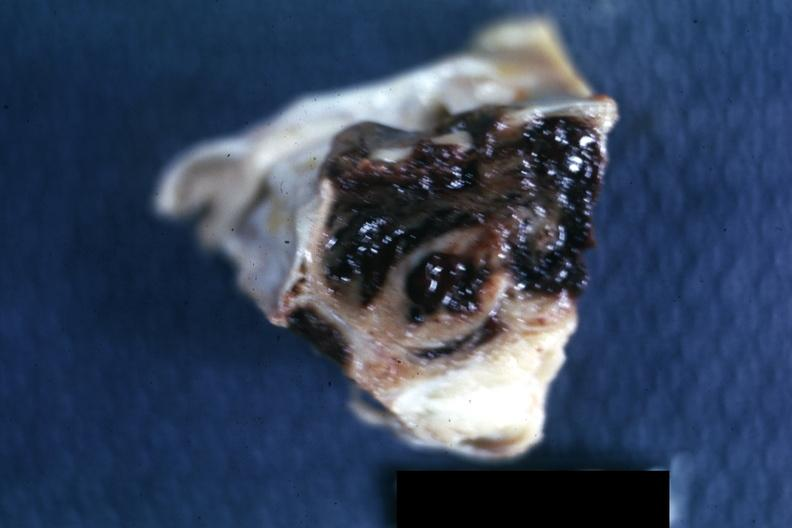s an opened peritoneal cavity cause by fibrous band strangulation present?
Answer the question using a single word or phrase. No 